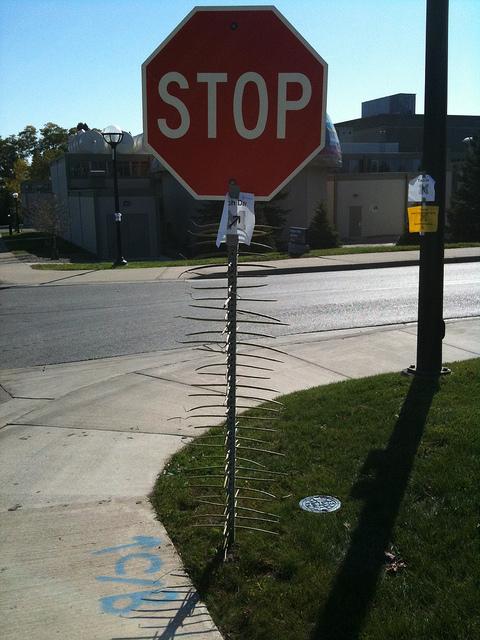What does the blue writing say?
Quick response, please. C/b. Is this a street corner?
Give a very brief answer. Yes. What words are on the sign?
Short answer required. Stop. 